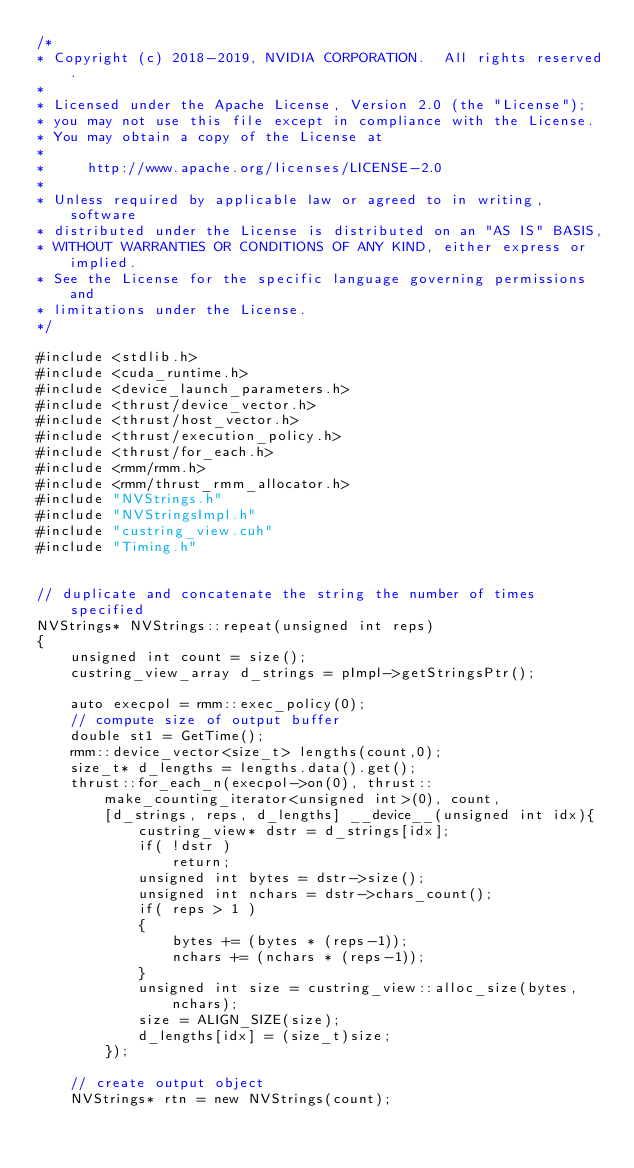Convert code to text. <code><loc_0><loc_0><loc_500><loc_500><_Cuda_>/*
* Copyright (c) 2018-2019, NVIDIA CORPORATION.  All rights reserved.
*
* Licensed under the Apache License, Version 2.0 (the "License");
* you may not use this file except in compliance with the License.
* You may obtain a copy of the License at
*
*     http://www.apache.org/licenses/LICENSE-2.0
*
* Unless required by applicable law or agreed to in writing, software
* distributed under the License is distributed on an "AS IS" BASIS,
* WITHOUT WARRANTIES OR CONDITIONS OF ANY KIND, either express or implied.
* See the License for the specific language governing permissions and
* limitations under the License.
*/

#include <stdlib.h>
#include <cuda_runtime.h>
#include <device_launch_parameters.h>
#include <thrust/device_vector.h>
#include <thrust/host_vector.h>
#include <thrust/execution_policy.h>
#include <thrust/for_each.h>
#include <rmm/rmm.h>
#include <rmm/thrust_rmm_allocator.h>
#include "NVStrings.h"
#include "NVStringsImpl.h"
#include "custring_view.cuh"
#include "Timing.h"


// duplicate and concatenate the string the number of times specified
NVStrings* NVStrings::repeat(unsigned int reps)
{
    unsigned int count = size();
    custring_view_array d_strings = pImpl->getStringsPtr();

    auto execpol = rmm::exec_policy(0);
    // compute size of output buffer
    double st1 = GetTime();
    rmm::device_vector<size_t> lengths(count,0);
    size_t* d_lengths = lengths.data().get();
    thrust::for_each_n(execpol->on(0), thrust::make_counting_iterator<unsigned int>(0), count,
        [d_strings, reps, d_lengths] __device__(unsigned int idx){
            custring_view* dstr = d_strings[idx];
            if( !dstr )
                return;
            unsigned int bytes = dstr->size();
            unsigned int nchars = dstr->chars_count();
            if( reps > 1 )
            {
                bytes += (bytes * (reps-1));
                nchars += (nchars * (reps-1));
            }
            unsigned int size = custring_view::alloc_size(bytes,nchars);
            size = ALIGN_SIZE(size);
            d_lengths[idx] = (size_t)size;
        });

    // create output object
    NVStrings* rtn = new NVStrings(count);</code> 